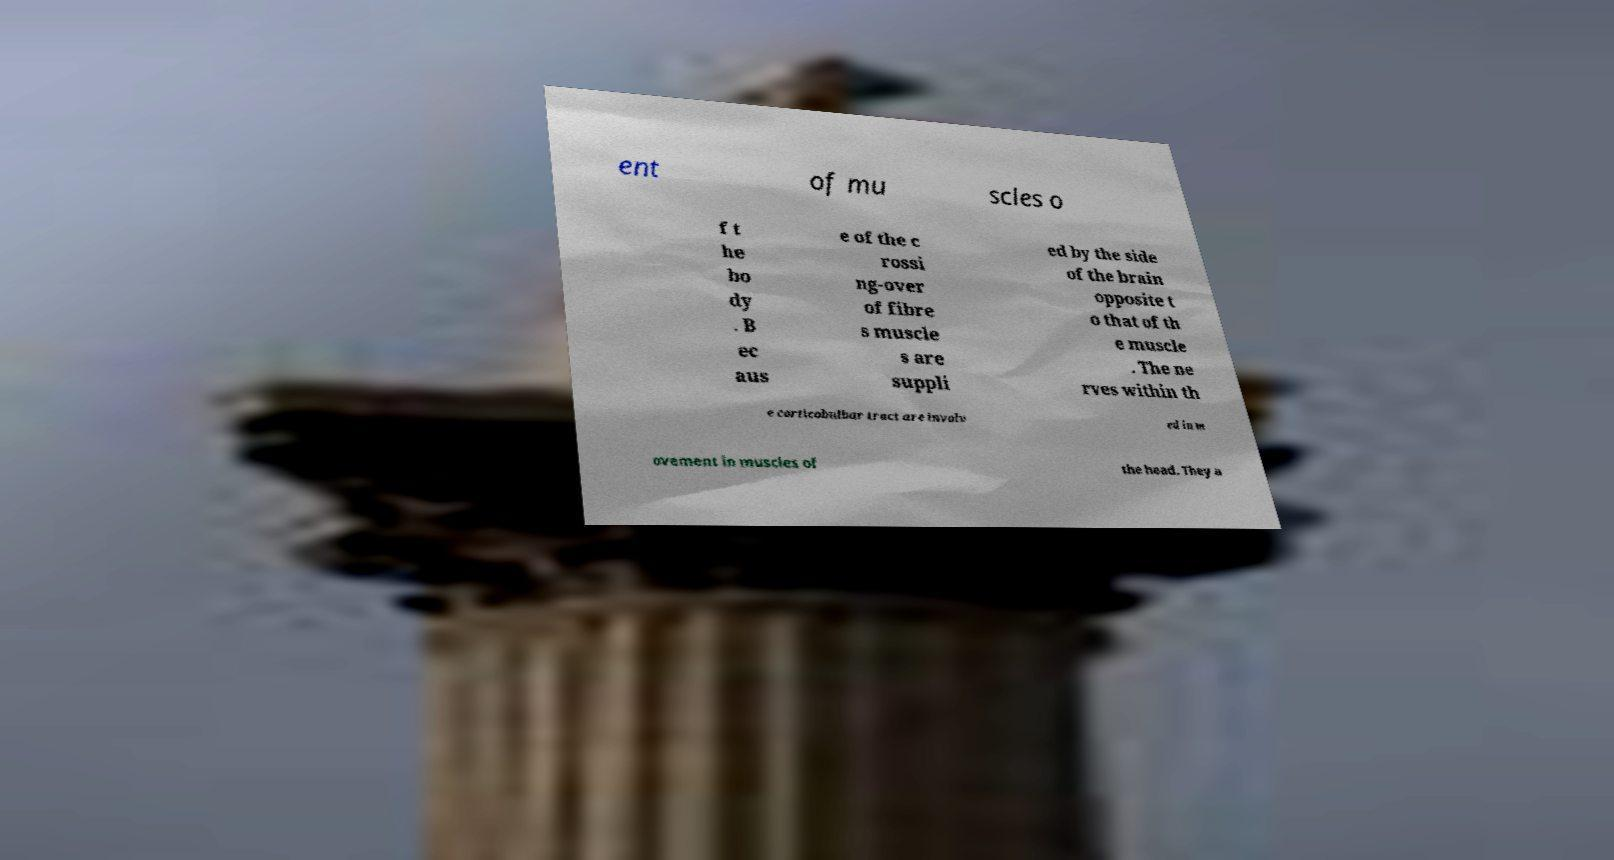Please identify and transcribe the text found in this image. ent of mu scles o f t he bo dy . B ec aus e of the c rossi ng-over of fibre s muscle s are suppli ed by the side of the brain opposite t o that of th e muscle . The ne rves within th e corticobulbar tract are involv ed in m ovement in muscles of the head. They a 